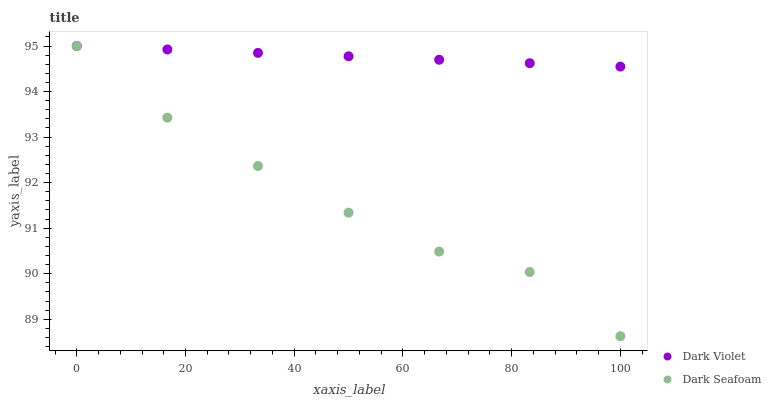Does Dark Seafoam have the minimum area under the curve?
Answer yes or no. Yes. Does Dark Violet have the maximum area under the curve?
Answer yes or no. Yes. Does Dark Violet have the minimum area under the curve?
Answer yes or no. No. Is Dark Violet the smoothest?
Answer yes or no. Yes. Is Dark Seafoam the roughest?
Answer yes or no. Yes. Is Dark Violet the roughest?
Answer yes or no. No. Does Dark Seafoam have the lowest value?
Answer yes or no. Yes. Does Dark Violet have the lowest value?
Answer yes or no. No. Does Dark Violet have the highest value?
Answer yes or no. Yes. Does Dark Seafoam intersect Dark Violet?
Answer yes or no. Yes. Is Dark Seafoam less than Dark Violet?
Answer yes or no. No. Is Dark Seafoam greater than Dark Violet?
Answer yes or no. No. 